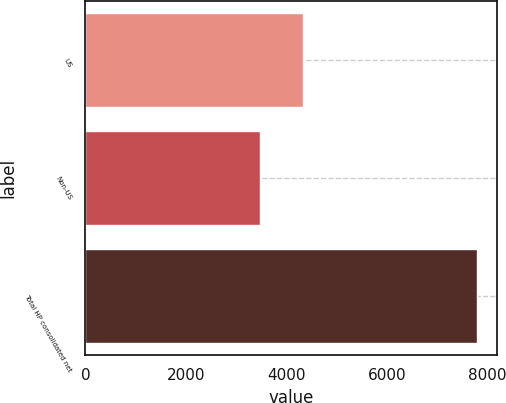Convert chart. <chart><loc_0><loc_0><loc_500><loc_500><bar_chart><fcel>US<fcel>Non-US<fcel>Total HP consolidated net<nl><fcel>4321<fcel>3477<fcel>7798<nl></chart> 